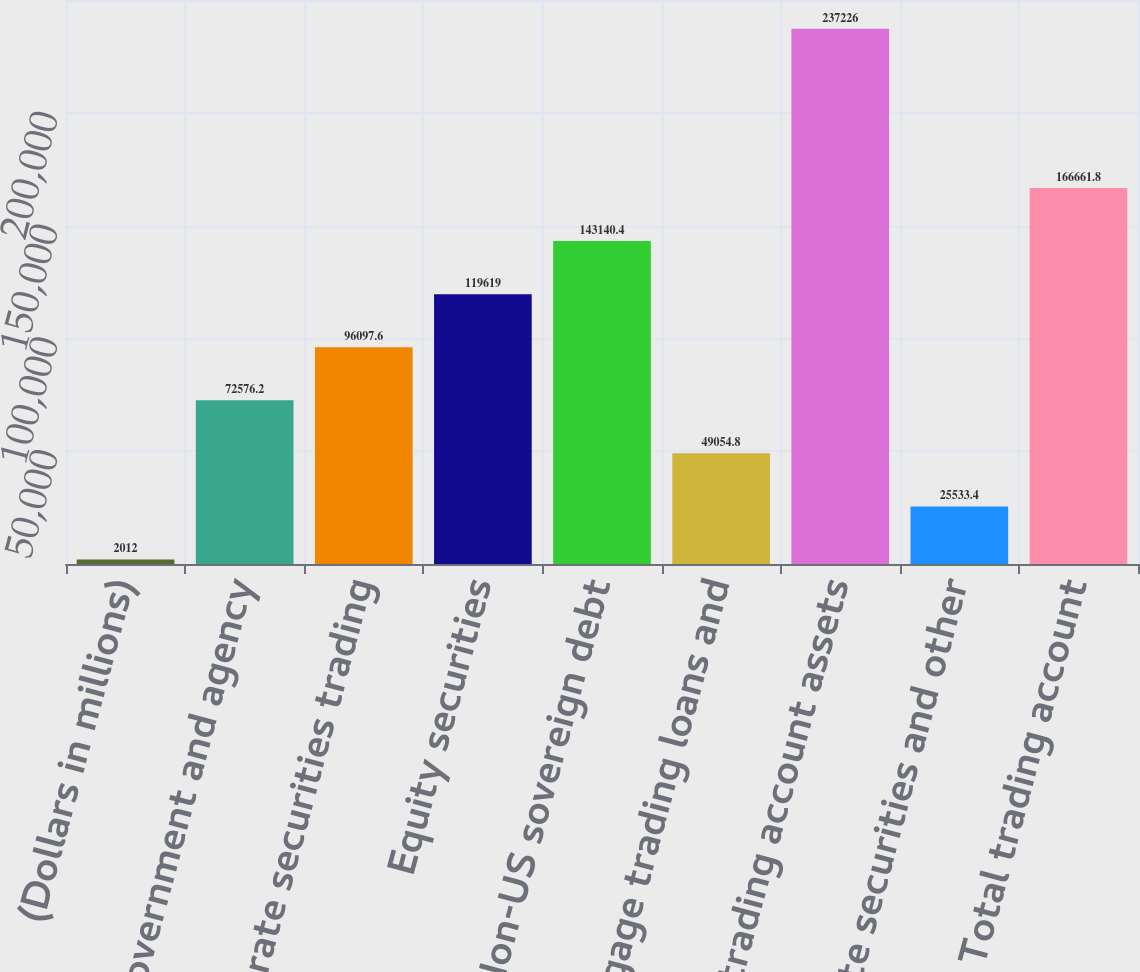<chart> <loc_0><loc_0><loc_500><loc_500><bar_chart><fcel>(Dollars in millions)<fcel>US government and agency<fcel>Corporate securities trading<fcel>Equity securities<fcel>Non-US sovereign debt<fcel>Mortgage trading loans and<fcel>Total trading account assets<fcel>Corporate securities and other<fcel>Total trading account<nl><fcel>2012<fcel>72576.2<fcel>96097.6<fcel>119619<fcel>143140<fcel>49054.8<fcel>237226<fcel>25533.4<fcel>166662<nl></chart> 